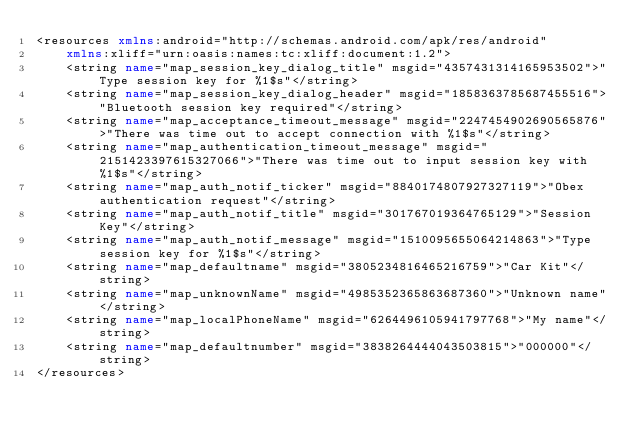Convert code to text. <code><loc_0><loc_0><loc_500><loc_500><_XML_><resources xmlns:android="http://schemas.android.com/apk/res/android"
    xmlns:xliff="urn:oasis:names:tc:xliff:document:1.2">
    <string name="map_session_key_dialog_title" msgid="4357431314165953502">"Type session key for %1$s"</string>
    <string name="map_session_key_dialog_header" msgid="1858363785687455516">"Bluetooth session key required"</string>
    <string name="map_acceptance_timeout_message" msgid="2247454902690565876">"There was time out to accept connection with %1$s"</string>
    <string name="map_authentication_timeout_message" msgid="2151423397615327066">"There was time out to input session key with %1$s"</string>
    <string name="map_auth_notif_ticker" msgid="8840174807927327119">"Obex authentication request"</string>
    <string name="map_auth_notif_title" msgid="301767019364765129">"Session Key"</string>
    <string name="map_auth_notif_message" msgid="1510095655064214863">"Type session key for %1$s"</string>
    <string name="map_defaultname" msgid="3805234816465216759">"Car Kit"</string>
    <string name="map_unknownName" msgid="4985352365863687360">"Unknown name"</string>
    <string name="map_localPhoneName" msgid="6264496105941797768">"My name"</string>
    <string name="map_defaultnumber" msgid="3838264444043503815">"000000"</string>
</resources>
</code> 